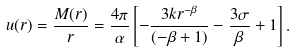<formula> <loc_0><loc_0><loc_500><loc_500>u ( r ) = \frac { M ( r ) } { r } = \frac { 4 \pi } { \alpha } \left [ - \frac { 3 k r ^ { - \beta } } { ( - \beta + 1 ) } - \frac { 3 \sigma } { \beta } + 1 \right ] .</formula> 